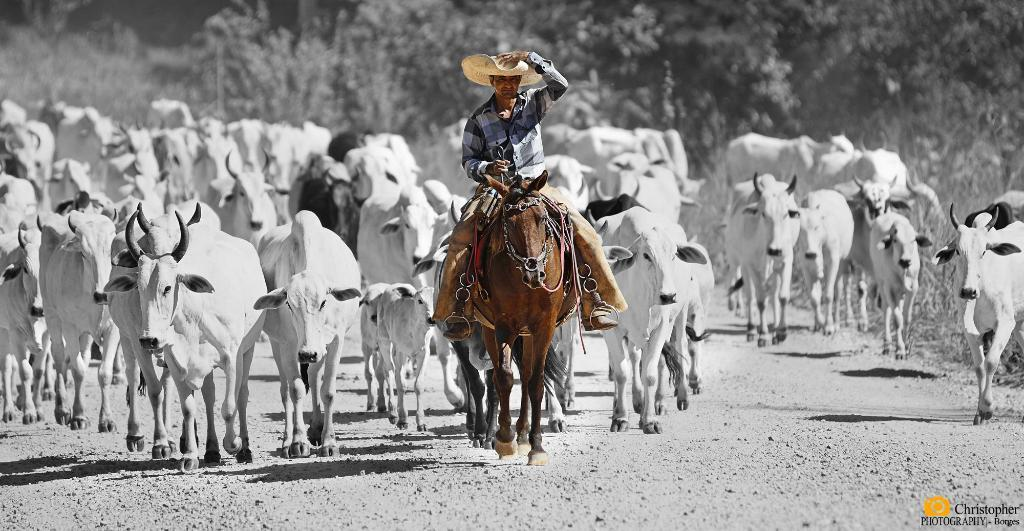What is the main subject of the image? There is a person riding a horse in the image. What can be seen in the background of the image? There are many cows and trees in the background of the image. What type of furniture can be seen in the image? There is no furniture present in the image; it features a person riding a horse and a background with cows and trees. 